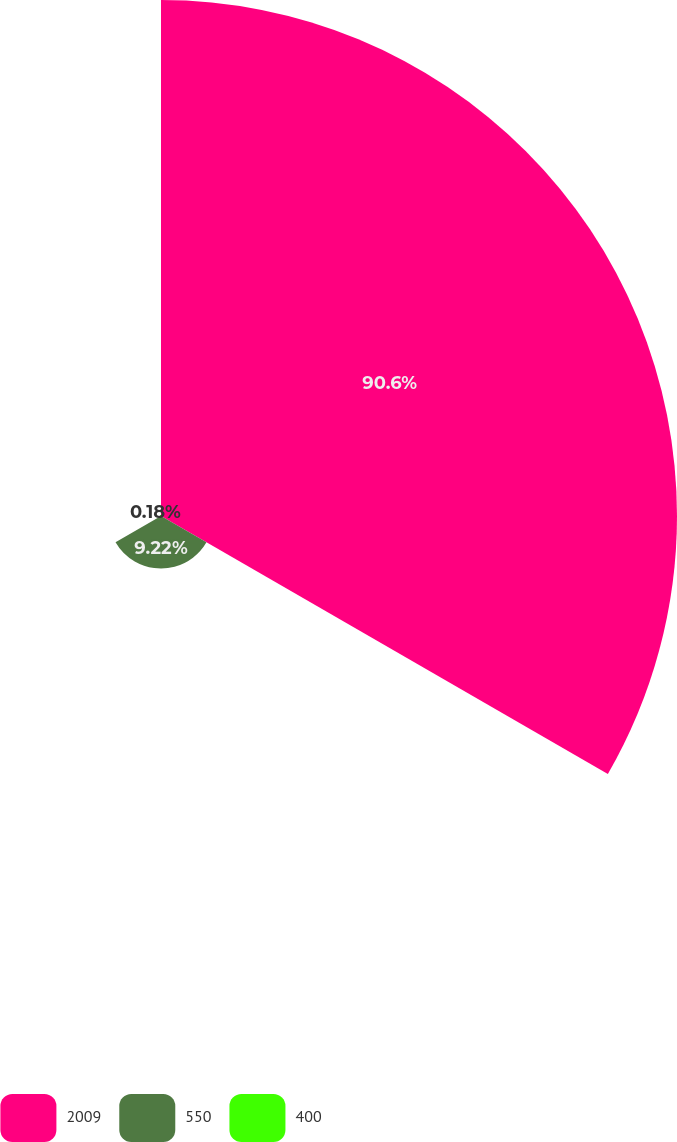Convert chart to OTSL. <chart><loc_0><loc_0><loc_500><loc_500><pie_chart><fcel>2009<fcel>550<fcel>400<nl><fcel>90.6%<fcel>9.22%<fcel>0.18%<nl></chart> 